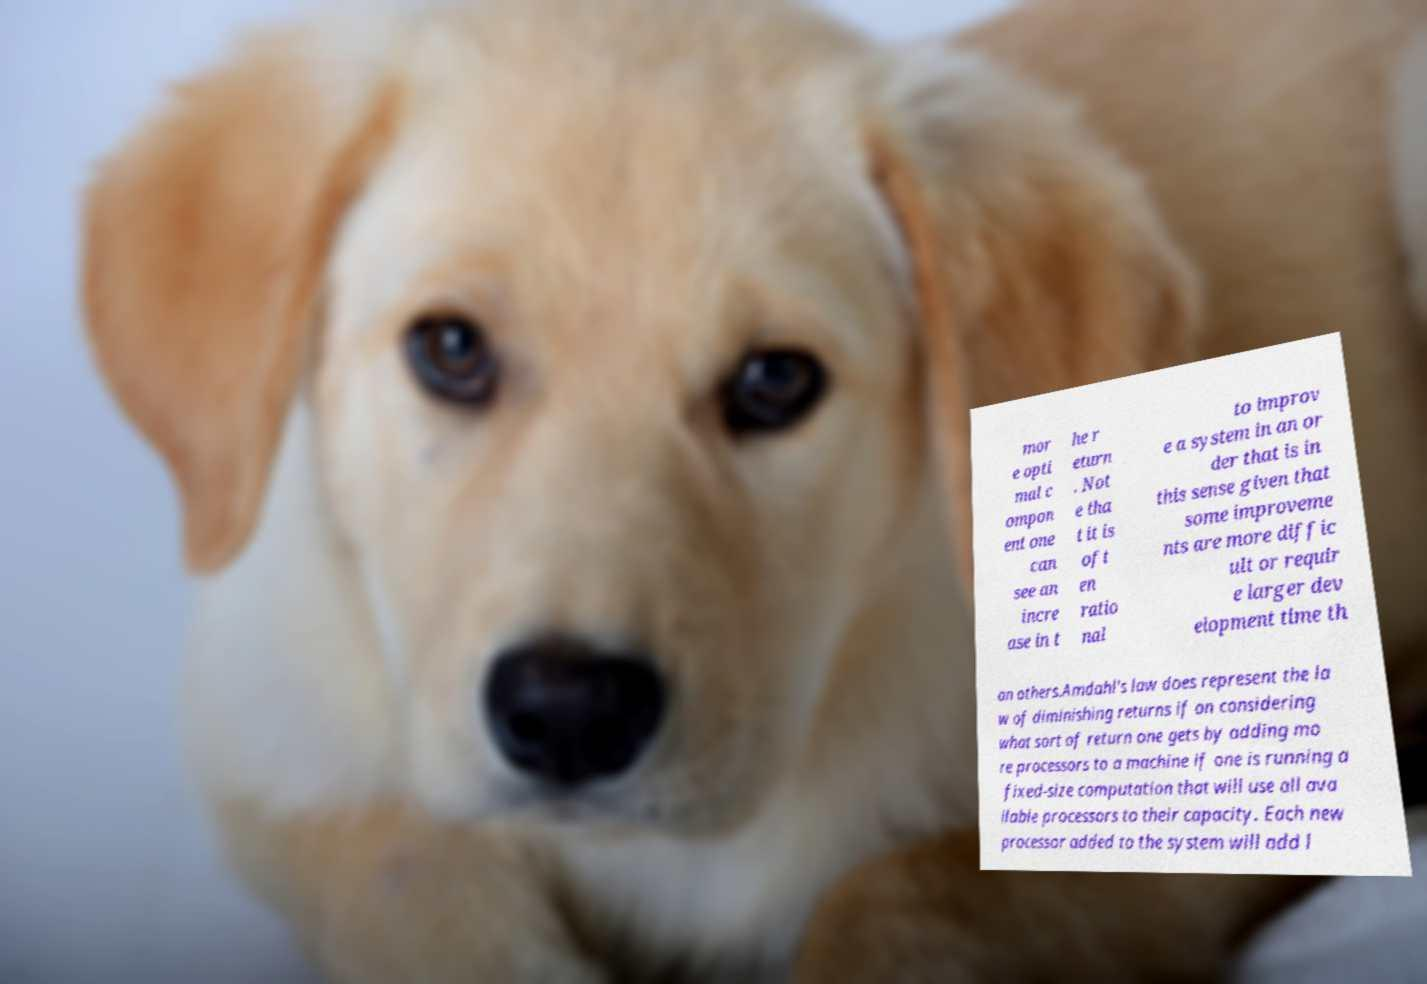For documentation purposes, I need the text within this image transcribed. Could you provide that? mor e opti mal c ompon ent one can see an incre ase in t he r eturn . Not e tha t it is oft en ratio nal to improv e a system in an or der that is in this sense given that some improveme nts are more diffic ult or requir e larger dev elopment time th an others.Amdahl's law does represent the la w of diminishing returns if on considering what sort of return one gets by adding mo re processors to a machine if one is running a fixed-size computation that will use all ava ilable processors to their capacity. Each new processor added to the system will add l 